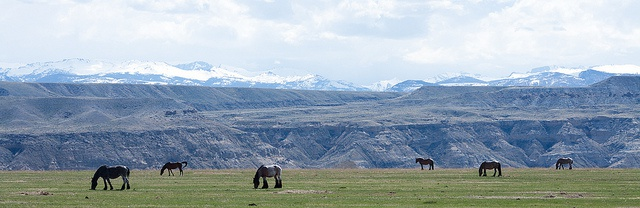Describe the objects in this image and their specific colors. I can see horse in lavender, black, gray, and blue tones, horse in lavender, black, gray, and darkgray tones, horse in lavender, black, gray, and darkgreen tones, horse in lavender, black, and gray tones, and horse in lavender, black, and gray tones in this image. 